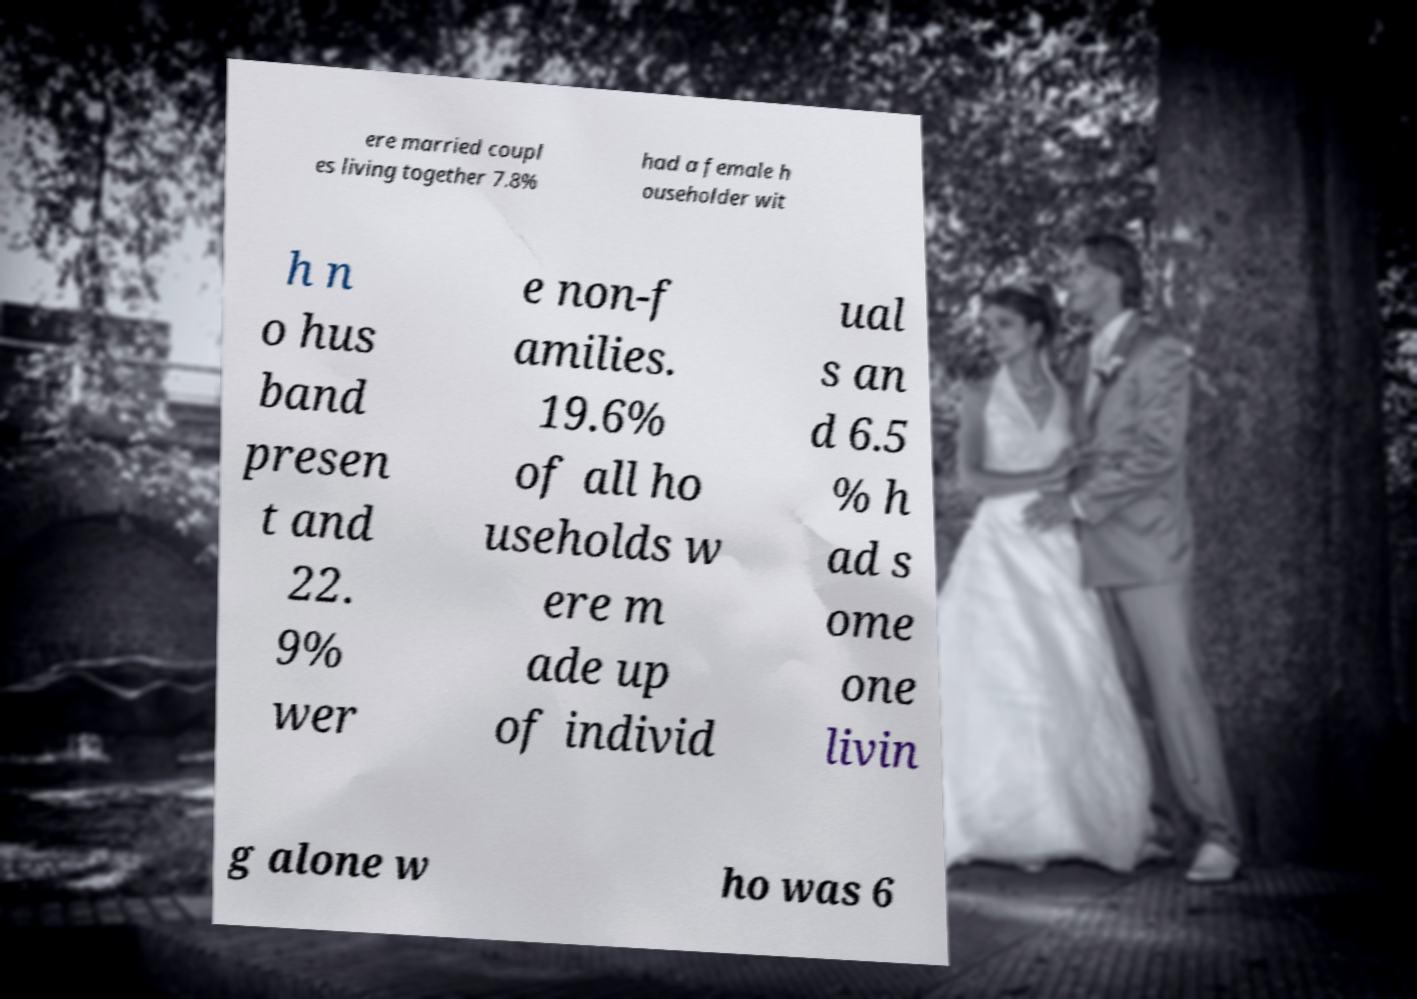For documentation purposes, I need the text within this image transcribed. Could you provide that? ere married coupl es living together 7.8% had a female h ouseholder wit h n o hus band presen t and 22. 9% wer e non-f amilies. 19.6% of all ho useholds w ere m ade up of individ ual s an d 6.5 % h ad s ome one livin g alone w ho was 6 